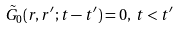<formula> <loc_0><loc_0><loc_500><loc_500>\tilde { G } _ { 0 } ( r , r ^ { \prime } ; t - t ^ { \prime } ) = 0 , \, t < t ^ { \prime }</formula> 